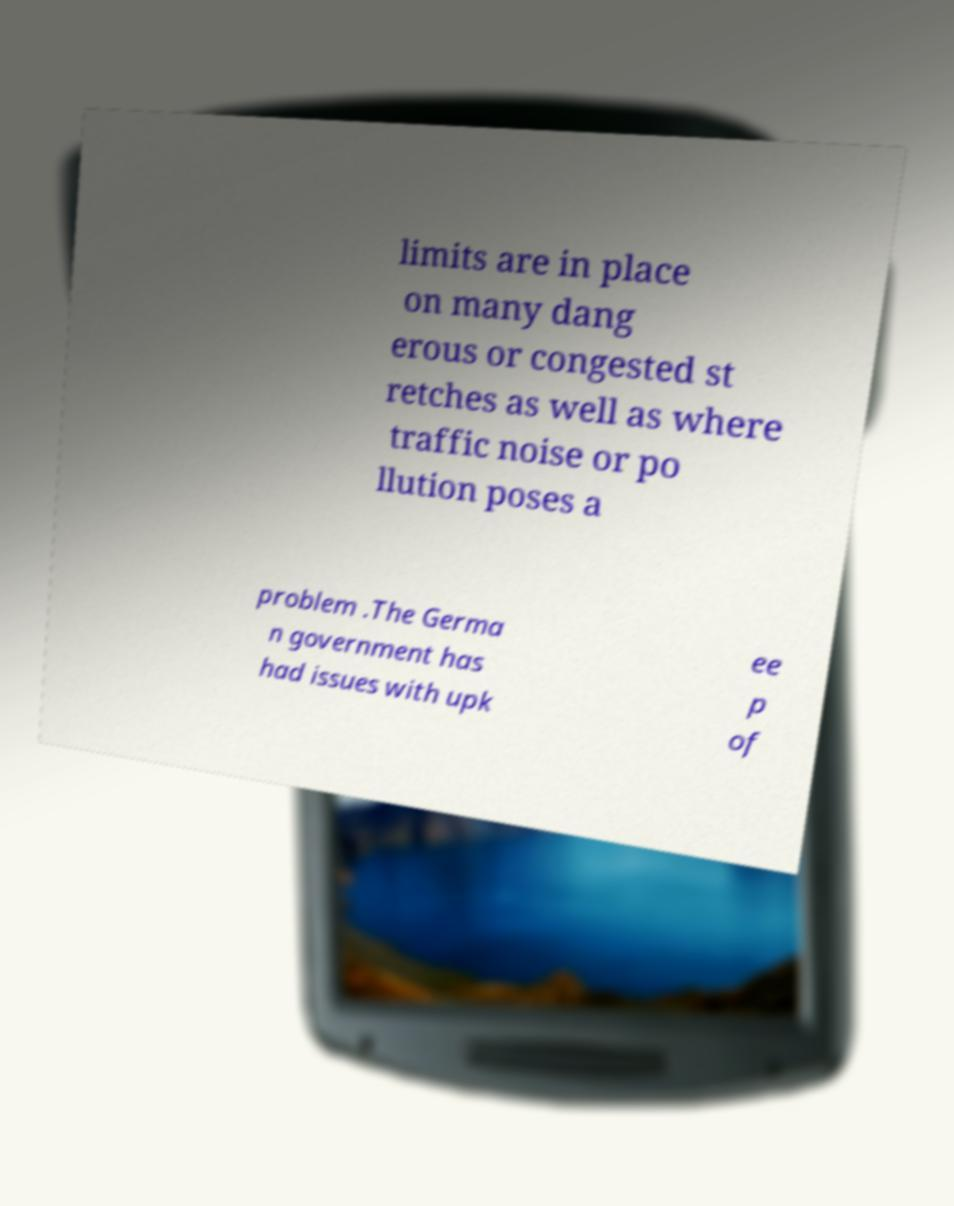Please identify and transcribe the text found in this image. limits are in place on many dang erous or congested st retches as well as where traffic noise or po llution poses a problem .The Germa n government has had issues with upk ee p of 